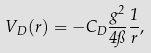<formula> <loc_0><loc_0><loc_500><loc_500>V _ { D } ( r ) = - C _ { D } \frac { g ^ { 2 } } { 4 \pi } \frac { 1 } { r } ,</formula> 